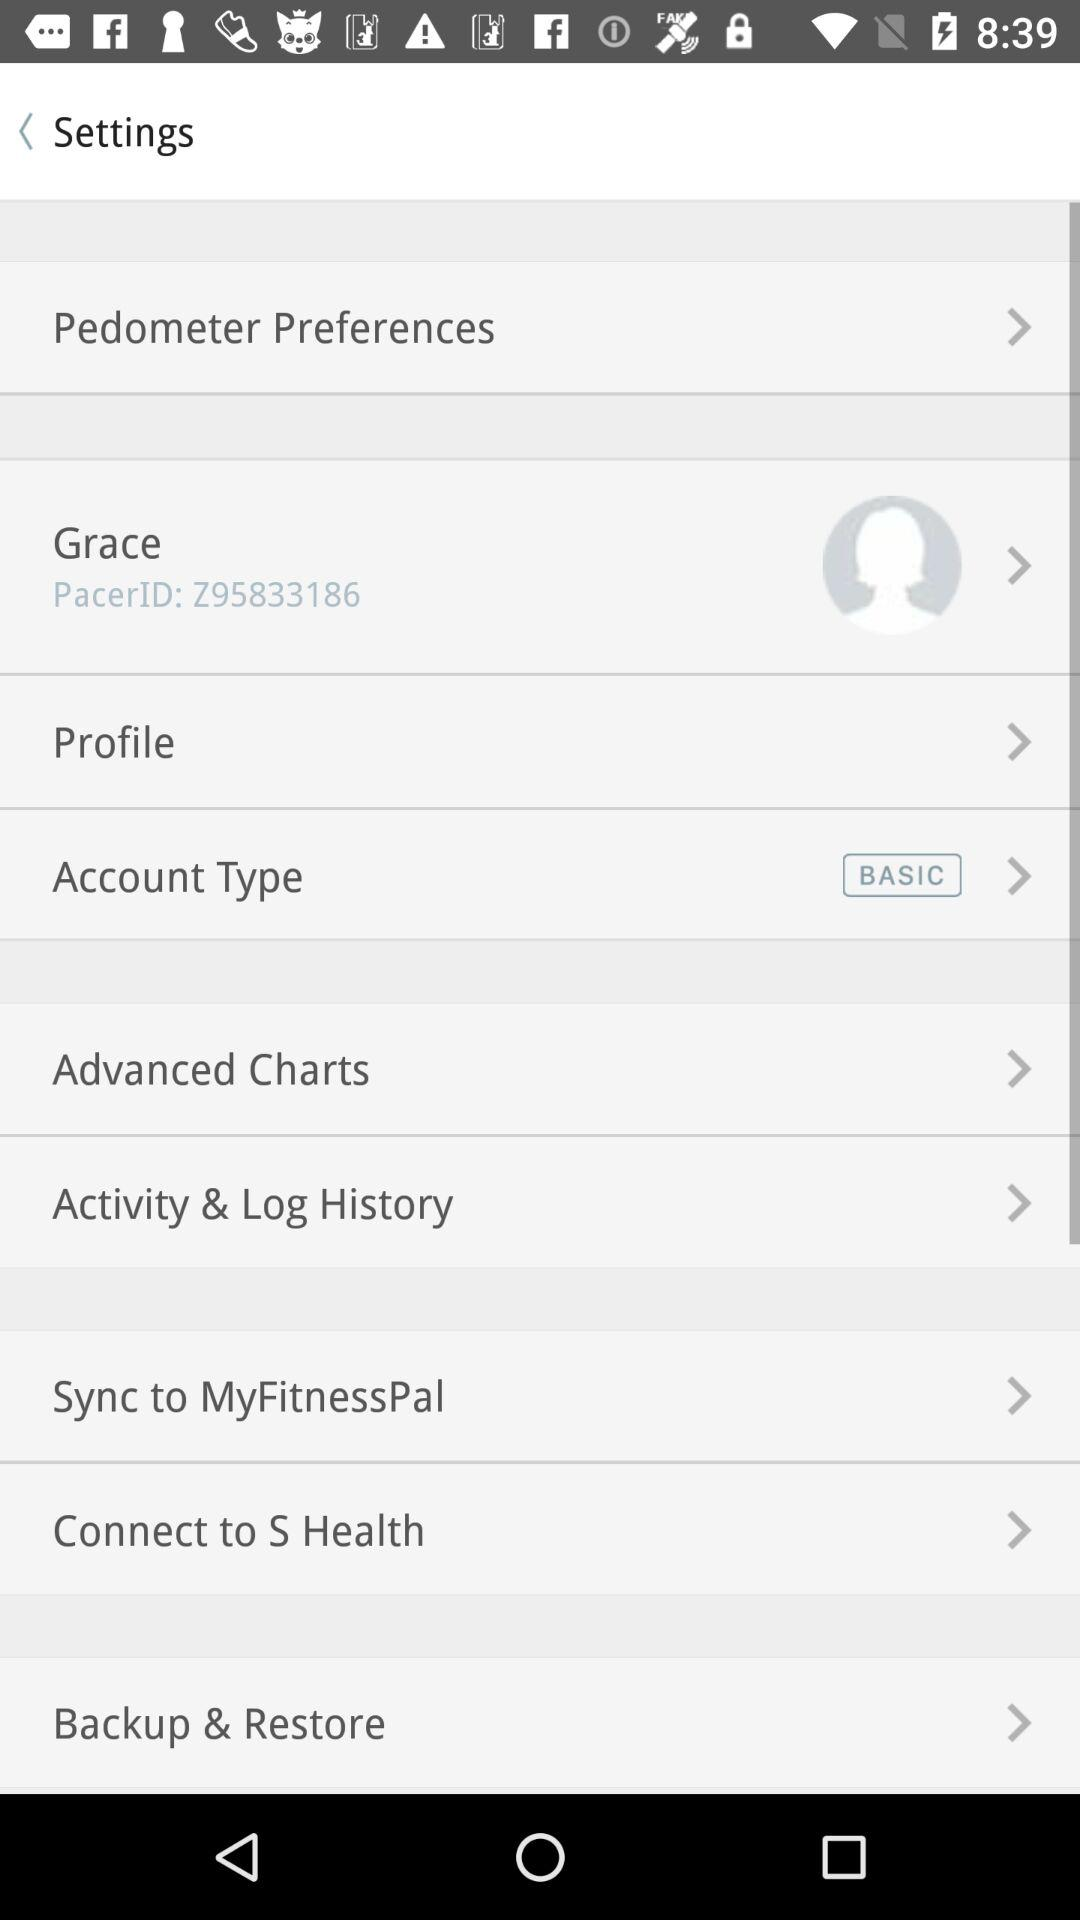What are the options available in settings? The available options are "Pedometer Preferences", "Grace", "Profile", "Account Type", "Advanced Charts", "Activity & Log History", "Sync to MyFitnessPal", "Connect to S Health" and "Backup & Restore". 